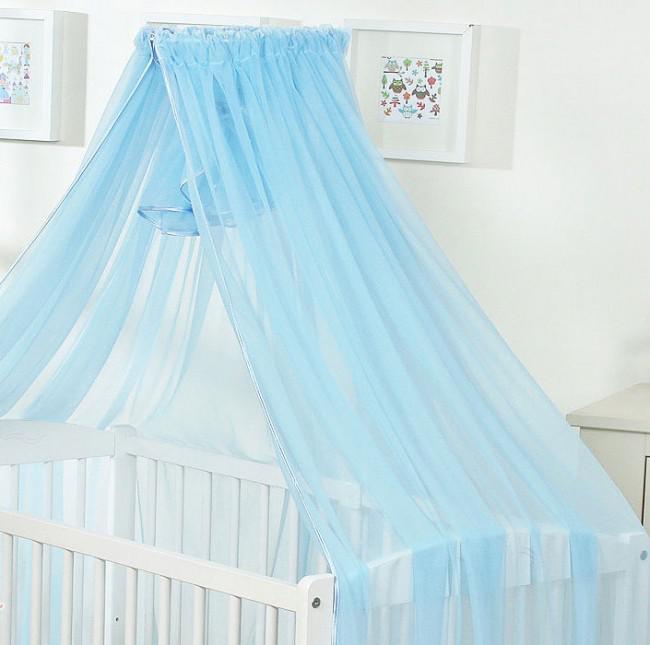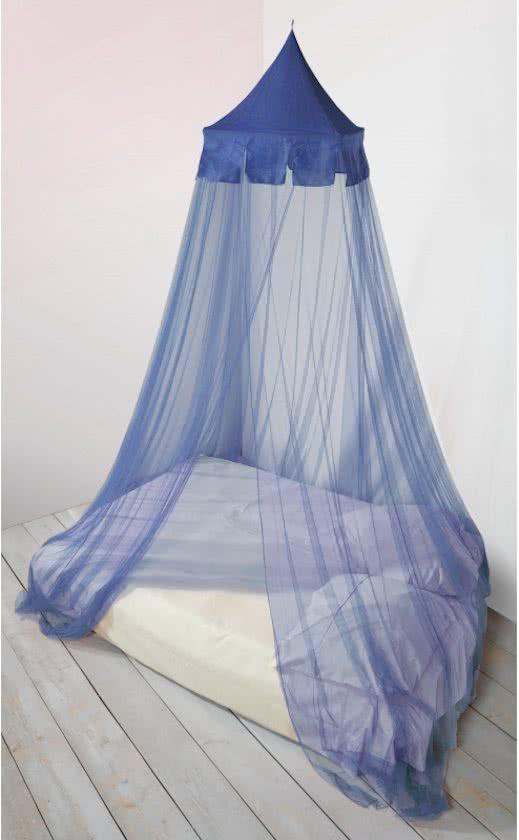The first image is the image on the left, the second image is the image on the right. For the images displayed, is the sentence "The left and right image contains the same number of blue canopies." factually correct? Answer yes or no. Yes. 